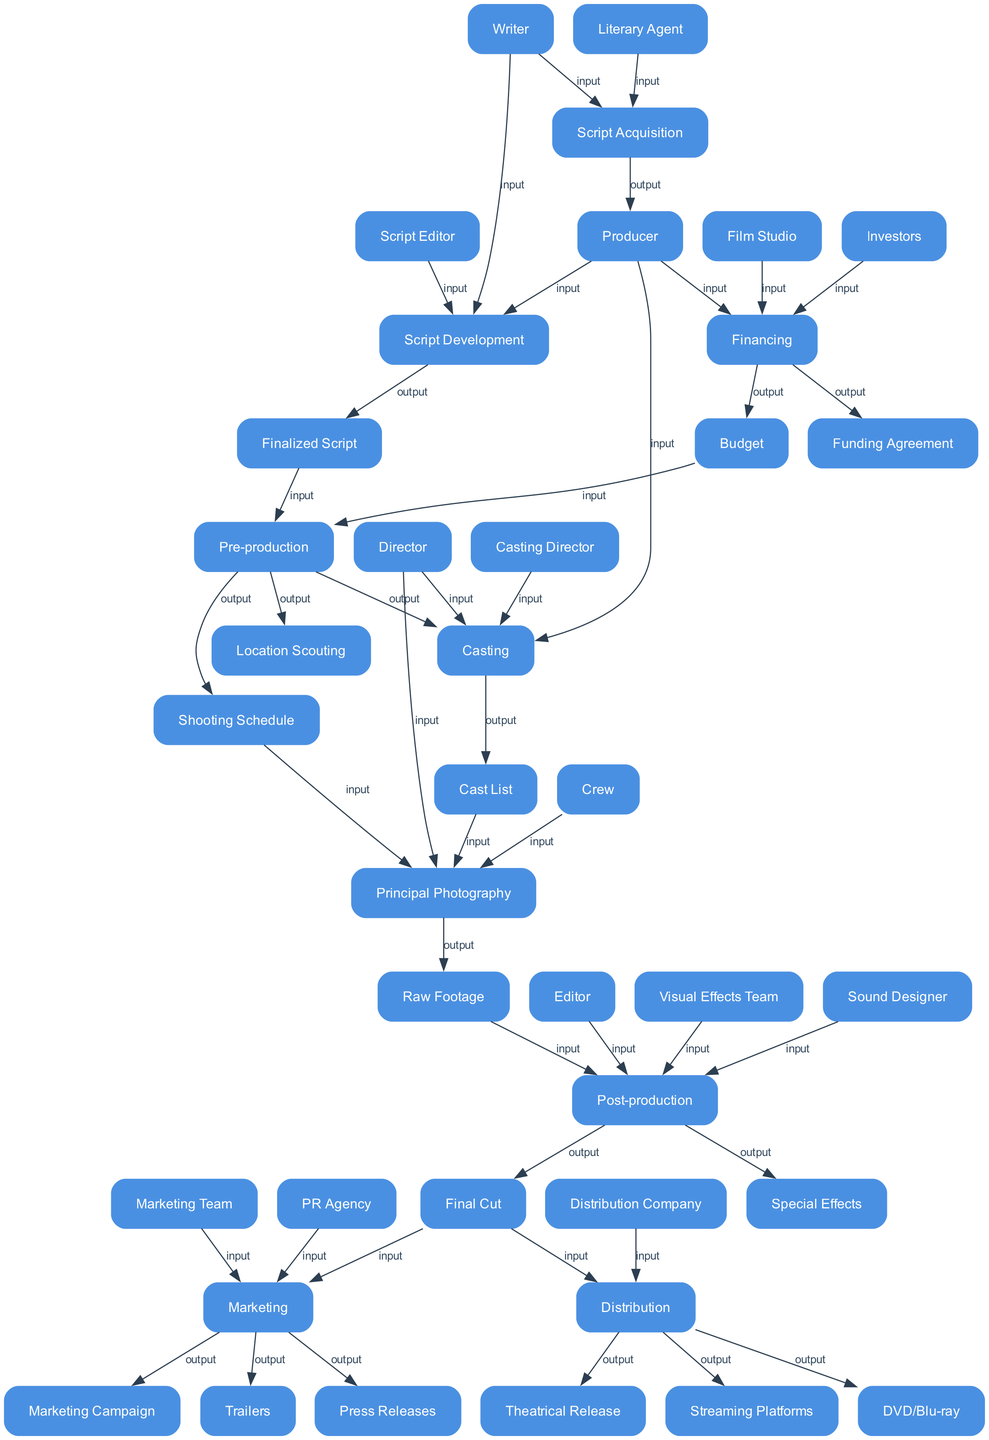What's the final output of the last process in the diagram? The last process in the diagram is 'Distribution', which produces outputs such as 'Theatrical Release', 'Streaming Platforms', and 'DVD/Blu-ray'. Among these, 'Theatrical Release' is the first mentioned output.
Answer: Theatrical Release How many inputs does 'Pre-production' have? The 'Pre-production' process has two inputs: 'Finalized Script' and 'Budget'. By counting these inputs, we determine that there are two of them.
Answer: 2 Which process produces the 'Final Cut'? The process that produces the 'Final Cut' is 'Post-production'. This is indicated as an output from the 'Post-production' process in the diagram.
Answer: Post-production What is the first step after 'Script Acquisition'? After 'Script Acquisition', the next process is 'Script Development'. This follows logically in the workflow as indicated in the diagram.
Answer: Script Development Which role is primarily responsible for securing funds during financing? The primary role responsible for securing funds during the 'Financing' process is the 'Producer'. This is reflected in the inputs of the 'Financing' stage.
Answer: Producer How many outputs does the 'Marketing' stage have? The 'Marketing' stage has three outputs: 'Marketing Campaign', 'Trailers', and 'Press Releases'. By listing these outputs, we find a total of three.
Answer: 3 What is the relationship between 'Casting' and 'Principal Photography'? The relationship is that 'Casting' provides the 'Cast List', which is an input for 'Principal Photography'. This indicates a direct flow from 'Casting' to 'Principal Photography' in the diagram.
Answer: Cast List Who collaborates alongside the Producer during 'Casting'? During 'Casting', the roles collaborating alongside the Producer are the 'Casting Director' and the 'Director'. This is clear from the inputs listed for the 'Casting' process.
Answer: Casting Director, Director What type of diagram is represented here? The diagram type represented here is a Data Flow Diagram, specifically illustrating the workflow and processes involved in film production from acquisition to release.
Answer: Data Flow Diagram 